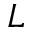<formula> <loc_0><loc_0><loc_500><loc_500>L</formula> 